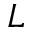<formula> <loc_0><loc_0><loc_500><loc_500>L</formula> 